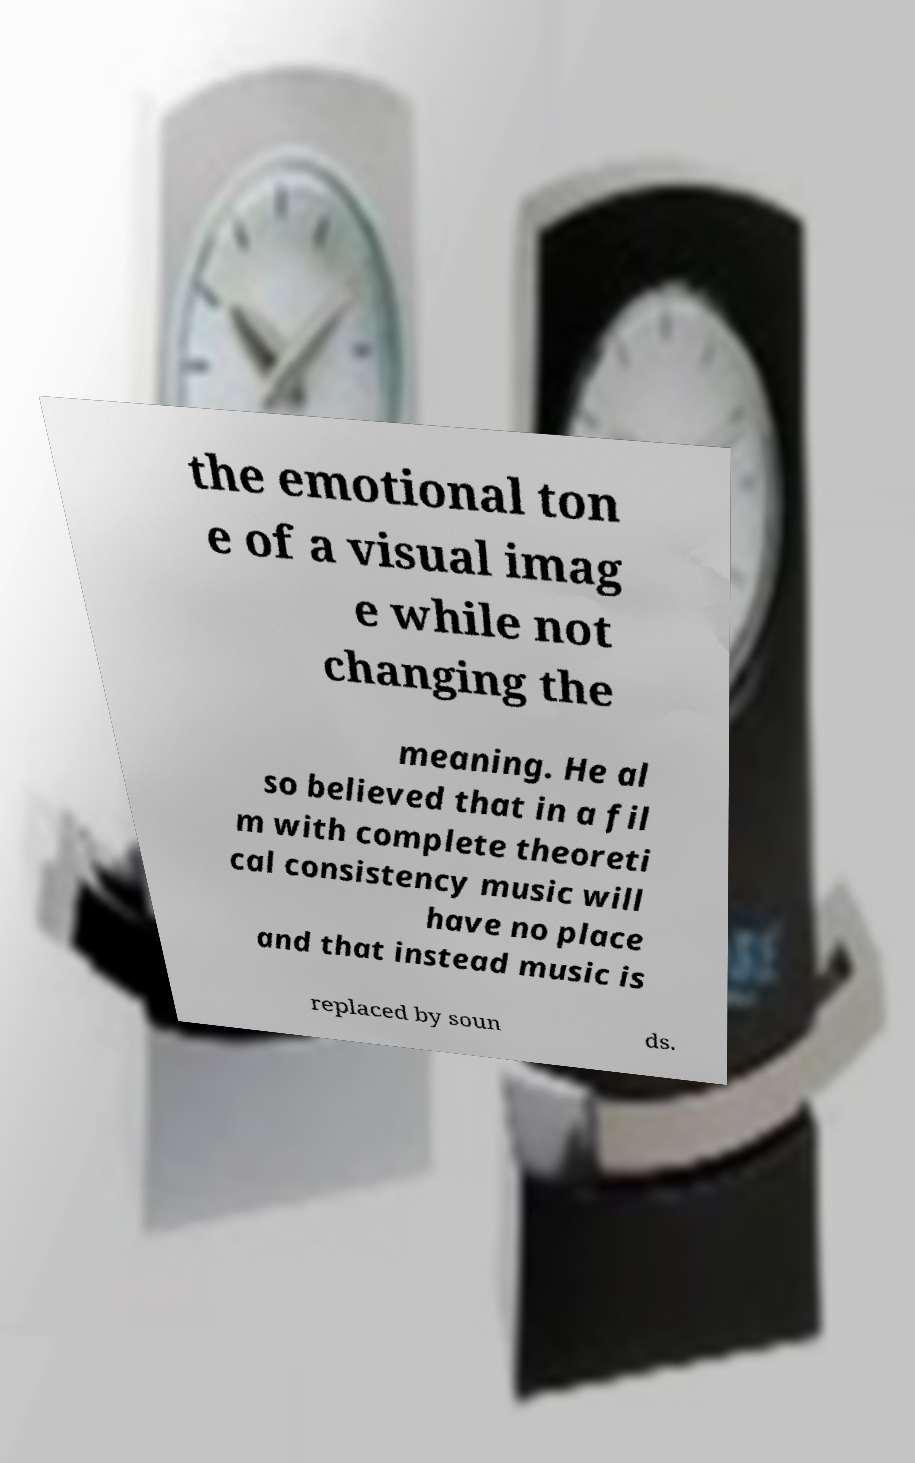Could you assist in decoding the text presented in this image and type it out clearly? the emotional ton e of a visual imag e while not changing the meaning. He al so believed that in a fil m with complete theoreti cal consistency music will have no place and that instead music is replaced by soun ds. 